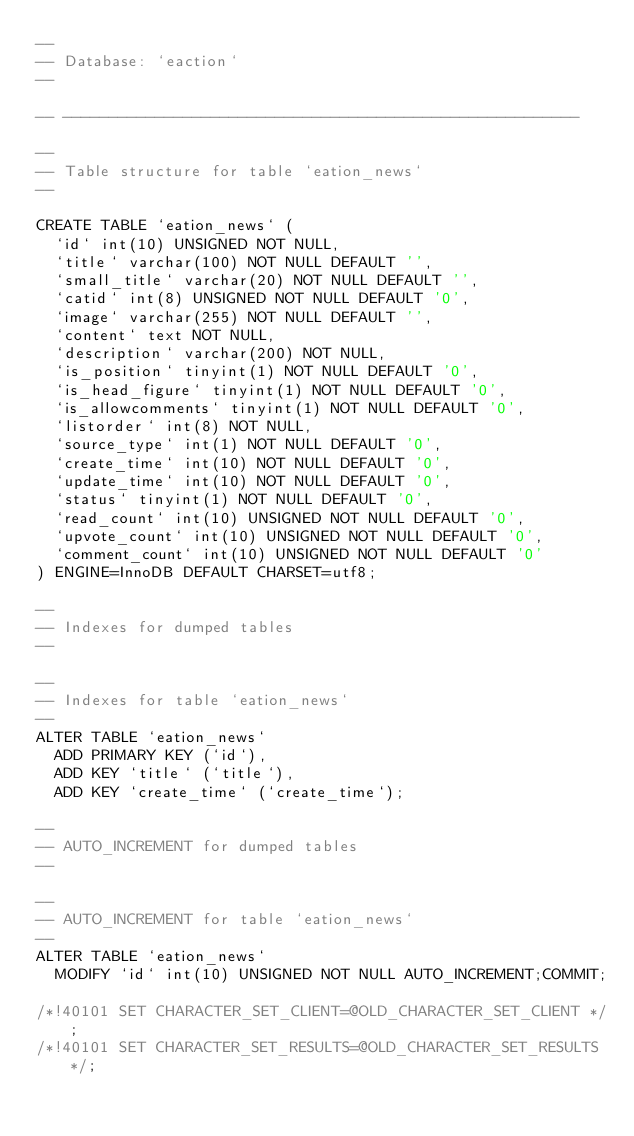Convert code to text. <code><loc_0><loc_0><loc_500><loc_500><_SQL_>--
-- Database: `eaction`
--

-- --------------------------------------------------------

--
-- Table structure for table `eation_news`
--

CREATE TABLE `eation_news` (
  `id` int(10) UNSIGNED NOT NULL,
  `title` varchar(100) NOT NULL DEFAULT '',
  `small_title` varchar(20) NOT NULL DEFAULT '',
  `catid` int(8) UNSIGNED NOT NULL DEFAULT '0',
  `image` varchar(255) NOT NULL DEFAULT '',
  `content` text NOT NULL,
  `description` varchar(200) NOT NULL,
  `is_position` tinyint(1) NOT NULL DEFAULT '0',
  `is_head_figure` tinyint(1) NOT NULL DEFAULT '0',
  `is_allowcomments` tinyint(1) NOT NULL DEFAULT '0',
  `listorder` int(8) NOT NULL,
  `source_type` int(1) NOT NULL DEFAULT '0',
  `create_time` int(10) NOT NULL DEFAULT '0',
  `update_time` int(10) NOT NULL DEFAULT '0',
  `status` tinyint(1) NOT NULL DEFAULT '0',
  `read_count` int(10) UNSIGNED NOT NULL DEFAULT '0',
  `upvote_count` int(10) UNSIGNED NOT NULL DEFAULT '0',
  `comment_count` int(10) UNSIGNED NOT NULL DEFAULT '0'
) ENGINE=InnoDB DEFAULT CHARSET=utf8;

--
-- Indexes for dumped tables
--

--
-- Indexes for table `eation_news`
--
ALTER TABLE `eation_news`
  ADD PRIMARY KEY (`id`),
  ADD KEY `title` (`title`),
  ADD KEY `create_time` (`create_time`);

--
-- AUTO_INCREMENT for dumped tables
--

--
-- AUTO_INCREMENT for table `eation_news`
--
ALTER TABLE `eation_news`
  MODIFY `id` int(10) UNSIGNED NOT NULL AUTO_INCREMENT;COMMIT;

/*!40101 SET CHARACTER_SET_CLIENT=@OLD_CHARACTER_SET_CLIENT */;
/*!40101 SET CHARACTER_SET_RESULTS=@OLD_CHARACTER_SET_RESULTS */;</code> 